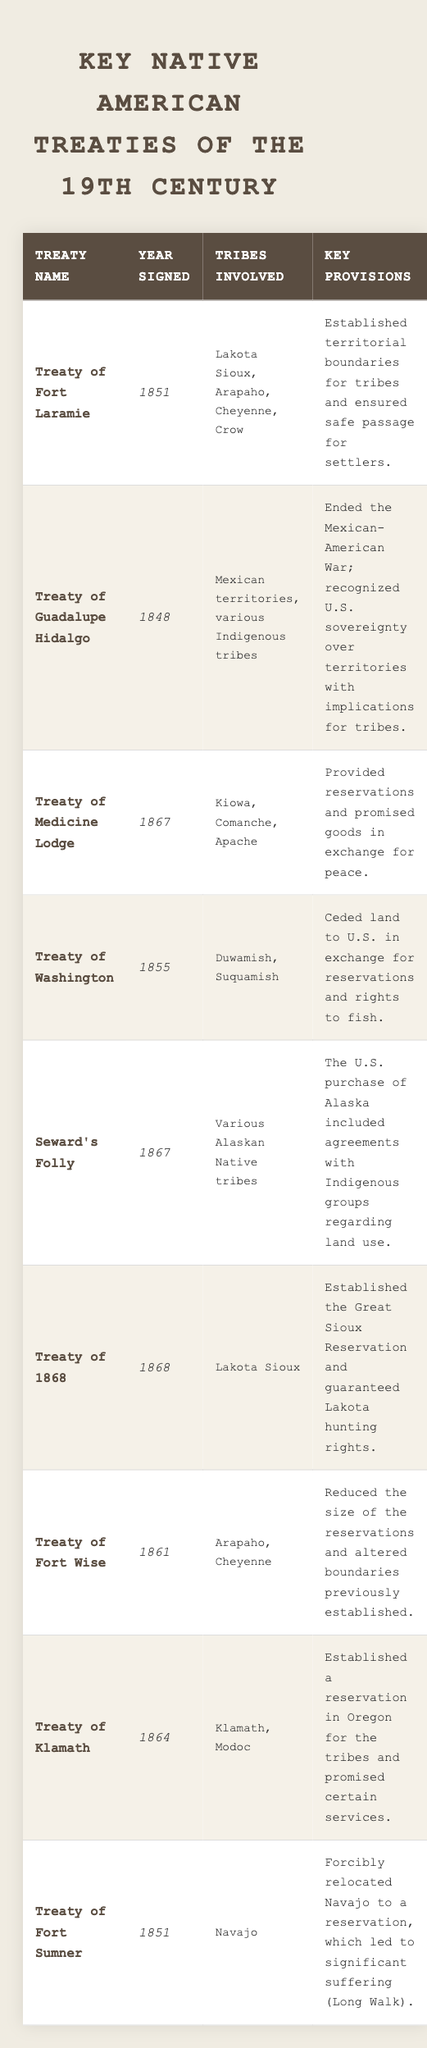What is the year in which the Treaty of Medicine Lodge was signed? The Treaty of Medicine Lodge was signed in the year column of the table, which shows 1867.
Answer: 1867 Which tribes were involved in the Treaty of Fort Laramie? The treaty specifically lists Lakota Sioux, Arapaho, Cheyenne, and Crow under the tribes involved column.
Answer: Lakota Sioux, Arapaho, Cheyenne, Crow How many treaties were signed in the year 1867? By counting the entries in the year column, there are three treaties signed in 1867: Treaty of Medicine Lodge, Seward's Folly, and Treaty of 1868.
Answer: 3 Did the Treaty of Washington involve the Navajo tribe? The Treaty of Washington does not list the Navajo tribe in its associated tribes column, which indicates that it was not involved.
Answer: No What was a key provision of the Treaty of 1868? Looking in the provisions column for the Treaty of 1868 reveals that it established the Great Sioux Reservation and guaranteed Lakota hunting rights.
Answer: Established the Great Sioux Reservation and guaranteed Lakota hunting rights Which treaty was signed first, the Treaty of Fort Wise or the Treaty of Fort Sumner? By comparing the years, the Treaty of Fort Wise was signed in 1861, and the Treaty of Fort Sumner was signed in 1851, thus the latter was signed first.
Answer: Treaty of Fort Sumner Is it true that the Treaty of Guadalupe Hidalgo affected various Indigenous tribes? The Treaty of Guadalupe Hidalgo mentions various Indigenous tribes in its tribes involved column, which supports that this statement is true.
Answer: Yes What is the relationship between the Treaties of Fort Laramie and Fort Sumner in terms of their year of signing? The Treaty of Fort Laramie was signed in 1851, and the Treaty of Fort Sumner was also signed in 1851; therefore, they were signed in the same year.
Answer: Same year Calculate the average year of the treaties listed in the table. To calculate the average year, sum the years (1848 + 1851 + 1861 + 1864 + 1867 + 1867 + 1868 + 1855 + 1851 = 16831), divide by the number of treaties (9): 16831/9 = 1860.11, or approximately 1860 when rounded to the nearest whole year.
Answer: 1860 Which treaty has a key provision that mentions relocation? The Treaty of Fort Sumner has a key provision that discusses the forced relocation of the Navajo, indicating it as the correct treaty.
Answer: Treaty of Fort Sumner Identify the tribes involved in the Treaty of Klamath. The table specifies Klamath and Modoc as the tribes involved in the Treaty of Klamath.
Answer: Klamath, Modoc 